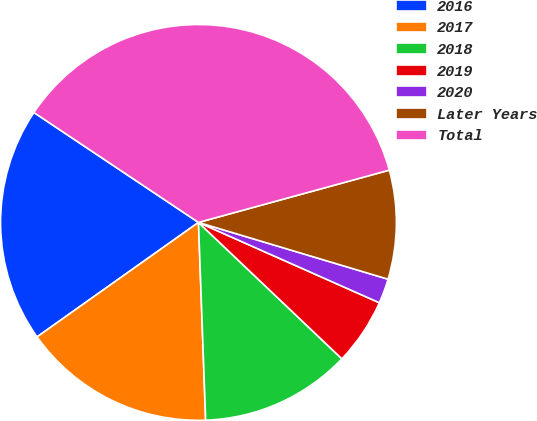Convert chart. <chart><loc_0><loc_0><loc_500><loc_500><pie_chart><fcel>2016<fcel>2017<fcel>2018<fcel>2019<fcel>2020<fcel>Later Years<fcel>Total<nl><fcel>19.19%<fcel>15.76%<fcel>12.32%<fcel>5.45%<fcel>2.02%<fcel>8.89%<fcel>36.37%<nl></chart> 